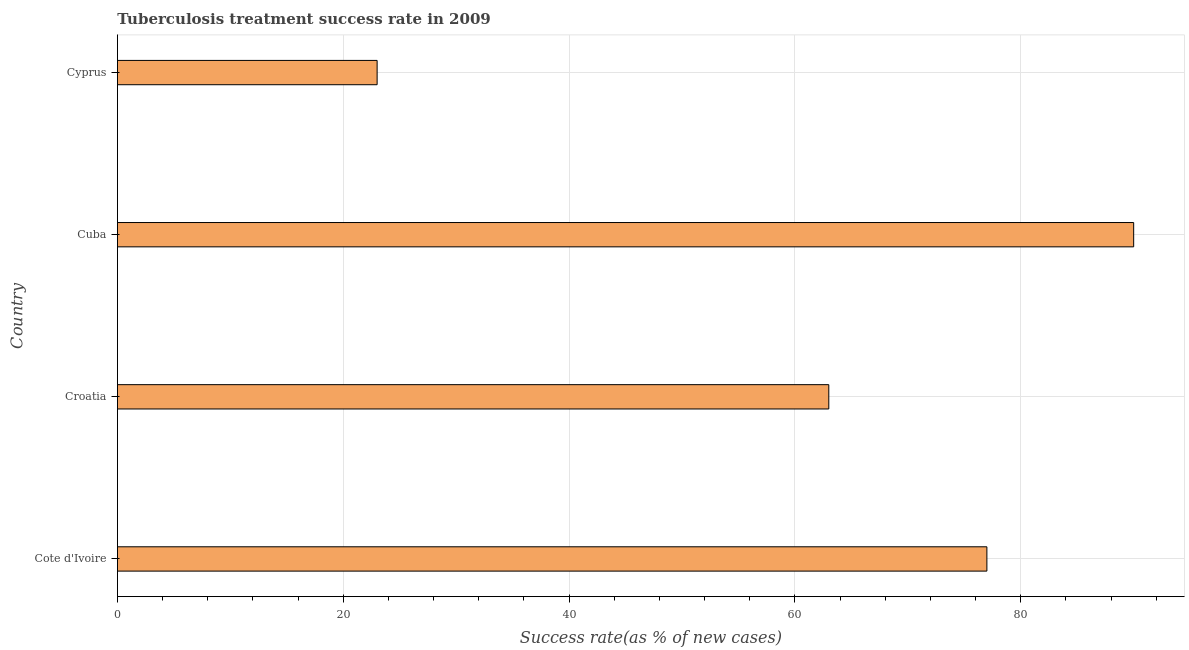Does the graph contain grids?
Ensure brevity in your answer.  Yes. What is the title of the graph?
Your response must be concise. Tuberculosis treatment success rate in 2009. What is the label or title of the X-axis?
Keep it short and to the point. Success rate(as % of new cases). What is the label or title of the Y-axis?
Ensure brevity in your answer.  Country. Across all countries, what is the maximum tuberculosis treatment success rate?
Offer a very short reply. 90. In which country was the tuberculosis treatment success rate maximum?
Make the answer very short. Cuba. In which country was the tuberculosis treatment success rate minimum?
Give a very brief answer. Cyprus. What is the sum of the tuberculosis treatment success rate?
Your answer should be very brief. 253. What is the difference between the tuberculosis treatment success rate in Croatia and Cyprus?
Keep it short and to the point. 40. In how many countries, is the tuberculosis treatment success rate greater than 36 %?
Your answer should be compact. 3. What is the ratio of the tuberculosis treatment success rate in Cuba to that in Cyprus?
Provide a short and direct response. 3.91. Is the difference between the tuberculosis treatment success rate in Cote d'Ivoire and Croatia greater than the difference between any two countries?
Provide a short and direct response. No. What is the difference between the highest and the second highest tuberculosis treatment success rate?
Give a very brief answer. 13. In how many countries, is the tuberculosis treatment success rate greater than the average tuberculosis treatment success rate taken over all countries?
Provide a short and direct response. 2. How many bars are there?
Give a very brief answer. 4. How many countries are there in the graph?
Your answer should be very brief. 4. What is the Success rate(as % of new cases) of Croatia?
Provide a short and direct response. 63. What is the Success rate(as % of new cases) in Cuba?
Offer a terse response. 90. What is the Success rate(as % of new cases) in Cyprus?
Keep it short and to the point. 23. What is the difference between the Success rate(as % of new cases) in Cote d'Ivoire and Croatia?
Offer a very short reply. 14. What is the difference between the Success rate(as % of new cases) in Cote d'Ivoire and Cyprus?
Provide a succinct answer. 54. What is the difference between the Success rate(as % of new cases) in Croatia and Cyprus?
Offer a very short reply. 40. What is the difference between the Success rate(as % of new cases) in Cuba and Cyprus?
Ensure brevity in your answer.  67. What is the ratio of the Success rate(as % of new cases) in Cote d'Ivoire to that in Croatia?
Make the answer very short. 1.22. What is the ratio of the Success rate(as % of new cases) in Cote d'Ivoire to that in Cuba?
Give a very brief answer. 0.86. What is the ratio of the Success rate(as % of new cases) in Cote d'Ivoire to that in Cyprus?
Ensure brevity in your answer.  3.35. What is the ratio of the Success rate(as % of new cases) in Croatia to that in Cuba?
Provide a short and direct response. 0.7. What is the ratio of the Success rate(as % of new cases) in Croatia to that in Cyprus?
Give a very brief answer. 2.74. What is the ratio of the Success rate(as % of new cases) in Cuba to that in Cyprus?
Ensure brevity in your answer.  3.91. 